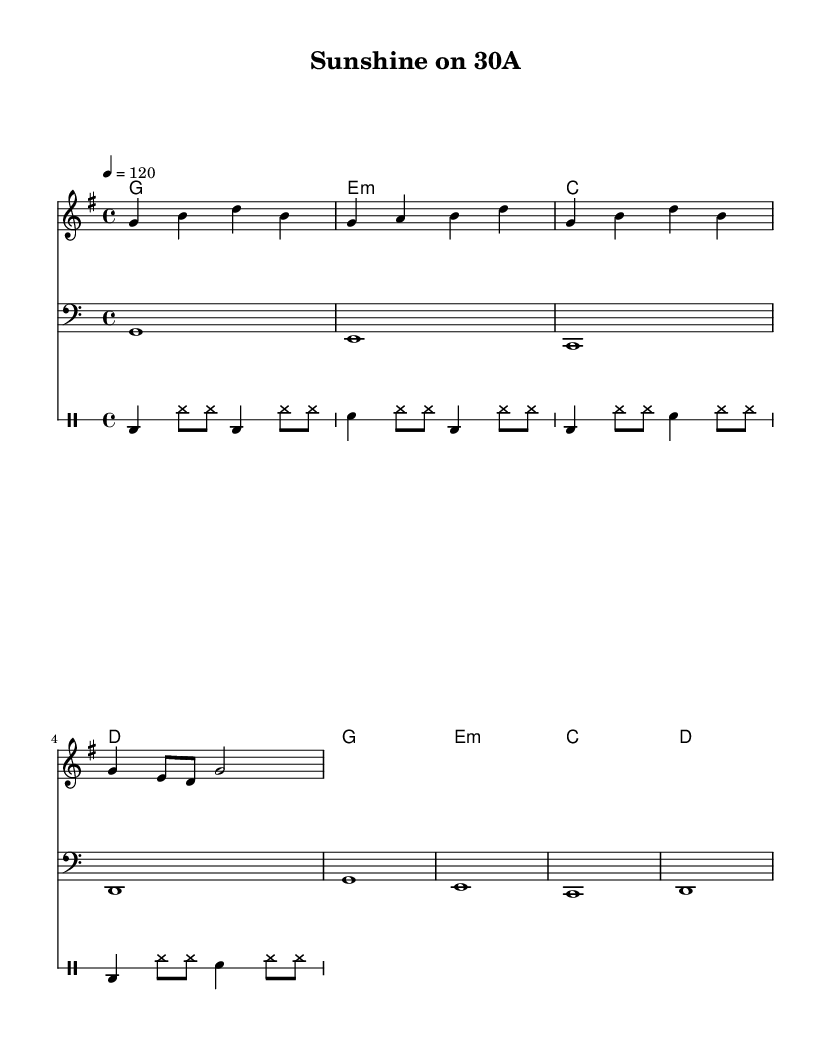What is the key signature of this music? The key signature indicates that this piece is in G major, which has one sharp (F#). This can be identified by looking at the key signature at the beginning of the sheet music.
Answer: G major What is the time signature of this piece? The time signature appears at the beginning of the score as 4/4, which means there are four beats in each measure, and the quarter note receives one beat. This is identifiable at the start of the sheet music.
Answer: 4/4 What is the tempo marking for this music? The tempo marking is shown as 4 = 120, which indicates that there are 120 beats per minute and the quarter note gets one beat. This is explicitly indicated in the tempo marking section.
Answer: 120 How many measures are there in the melody? By counting the measures in the melody part, you can see that there are a total of 4 measures, as indicated by the music notation. Each group of notes is separated by vertical lines representing the end of each measure.
Answer: 4 What type of R&B song is this score likely to be? The song appears to have an upbeat and family-friendly theme, which is characteristic of feel-good and celebratory R&B songs that are often suitable for road trips. This can be inferred from the lyrics and overall feel of the music.
Answer: Upbeat What instruments are included in this score? The score includes a melody line, bass line, chord symbols, and a drum part, indicating that it is arranged for multiple instruments including melody, bass, and percussion. The presence of different staves suggests a variety of instrumental arrangement.
Answer: Melody, bass, drums What is the central theme of the lyrics? The lyrics suggest a theme of family fun and adventure, emphasizing enjoyable road trips to South Walton and making memories together, as highlighted in the lyrical content provided. The overall message centers around positivity and togetherness.
Answer: Family fun 